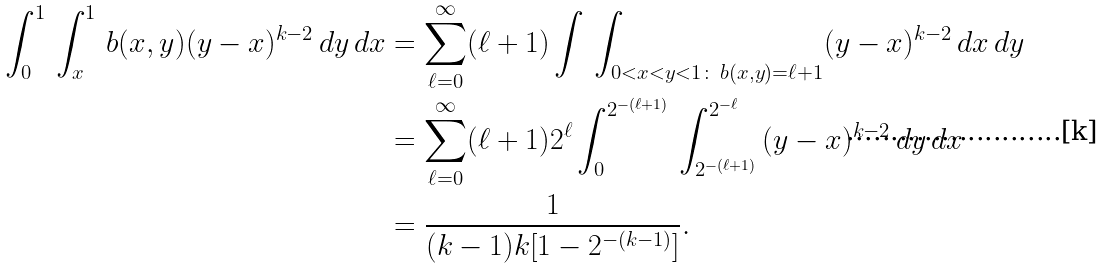<formula> <loc_0><loc_0><loc_500><loc_500>\int ^ { 1 } _ { 0 } \, \int ^ { 1 } _ { x } \, b ( x , y ) ( y - x ) ^ { k - 2 } \, d y \, d x & = \sum _ { \ell = 0 } ^ { \infty } ( \ell + 1 ) \int \, \int _ { 0 < x < y < 1 \colon \, b ( x , y ) = \ell + 1 } ( y - x ) ^ { k - 2 } \, d x \, d y \\ & = \sum _ { \ell = 0 } ^ { \infty } ( \ell + 1 ) 2 ^ { \ell } \int ^ { 2 ^ { - ( \ell + 1 ) } } _ { 0 } \, \int ^ { 2 ^ { - \ell } } _ { 2 ^ { - ( \ell + 1 ) } } \, ( y - x ) ^ { k - 2 } \, d y \, d x \\ & = \frac { 1 } { ( k - 1 ) k [ 1 - 2 ^ { - ( k - 1 ) } ] } .</formula> 